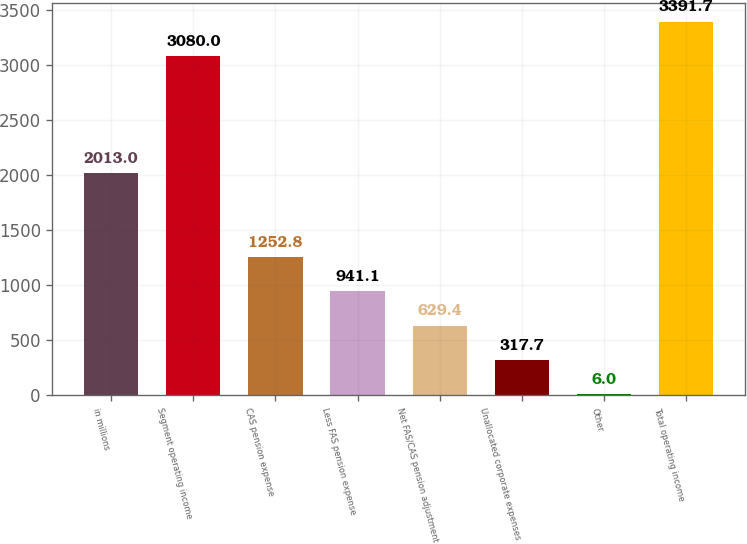Convert chart to OTSL. <chart><loc_0><loc_0><loc_500><loc_500><bar_chart><fcel>in millions<fcel>Segment operating income<fcel>CAS pension expense<fcel>Less FAS pension expense<fcel>Net FAS/CAS pension adjustment<fcel>Unallocated corporate expenses<fcel>Other<fcel>Total operating income<nl><fcel>2013<fcel>3080<fcel>1252.8<fcel>941.1<fcel>629.4<fcel>317.7<fcel>6<fcel>3391.7<nl></chart> 